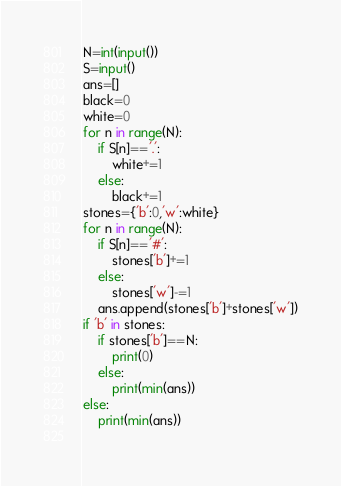Convert code to text. <code><loc_0><loc_0><loc_500><loc_500><_Python_>N=int(input())
S=input()
ans=[]
black=0
white=0
for n in range(N):
    if S[n]=='.':
        white+=1
    else:
        black+=1
stones={'b':0,'w':white}
for n in range(N):
    if S[n]=='#':
        stones['b']+=1
    else:
        stones['w']-=1
    ans.append(stones['b']+stones['w'])
if 'b' in stones:
    if stones['b']==N:
        print(0)
    else:
        print(min(ans))
else:
    print(min(ans))
    </code> 